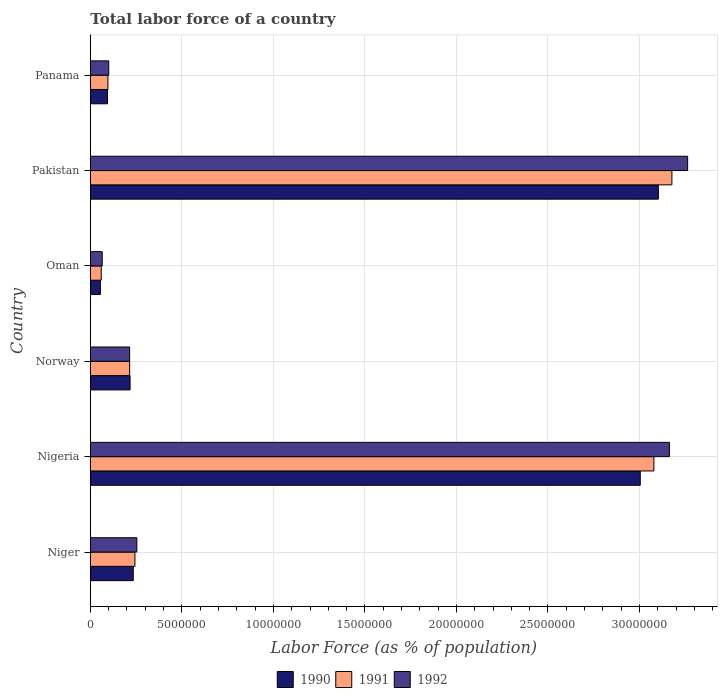How many different coloured bars are there?
Provide a succinct answer. 3. Are the number of bars on each tick of the Y-axis equal?
Your answer should be very brief. Yes. How many bars are there on the 1st tick from the bottom?
Your answer should be compact. 3. What is the label of the 1st group of bars from the top?
Make the answer very short. Panama. What is the percentage of labor force in 1991 in Niger?
Provide a short and direct response. 2.44e+06. Across all countries, what is the maximum percentage of labor force in 1991?
Provide a short and direct response. 3.18e+07. Across all countries, what is the minimum percentage of labor force in 1990?
Ensure brevity in your answer.  5.48e+05. In which country was the percentage of labor force in 1991 maximum?
Offer a very short reply. Pakistan. In which country was the percentage of labor force in 1990 minimum?
Make the answer very short. Oman. What is the total percentage of labor force in 1991 in the graph?
Give a very brief answer. 6.87e+07. What is the difference between the percentage of labor force in 1991 in Norway and that in Panama?
Offer a terse response. 1.18e+06. What is the difference between the percentage of labor force in 1990 in Norway and the percentage of labor force in 1991 in Oman?
Make the answer very short. 1.57e+06. What is the average percentage of labor force in 1992 per country?
Your answer should be compact. 1.18e+07. What is the difference between the percentage of labor force in 1990 and percentage of labor force in 1992 in Niger?
Make the answer very short. -1.97e+05. What is the ratio of the percentage of labor force in 1991 in Nigeria to that in Oman?
Provide a succinct answer. 51.79. What is the difference between the highest and the second highest percentage of labor force in 1990?
Offer a terse response. 9.88e+05. What is the difference between the highest and the lowest percentage of labor force in 1991?
Give a very brief answer. 3.12e+07. In how many countries, is the percentage of labor force in 1991 greater than the average percentage of labor force in 1991 taken over all countries?
Your answer should be compact. 2. Is the sum of the percentage of labor force in 1991 in Nigeria and Norway greater than the maximum percentage of labor force in 1992 across all countries?
Provide a short and direct response. Yes. What is the difference between two consecutive major ticks on the X-axis?
Keep it short and to the point. 5.00e+06. Are the values on the major ticks of X-axis written in scientific E-notation?
Provide a short and direct response. No. Does the graph contain grids?
Your answer should be compact. Yes. Where does the legend appear in the graph?
Give a very brief answer. Bottom center. How many legend labels are there?
Provide a succinct answer. 3. How are the legend labels stacked?
Give a very brief answer. Horizontal. What is the title of the graph?
Offer a very short reply. Total labor force of a country. What is the label or title of the X-axis?
Provide a short and direct response. Labor Force (as % of population). What is the Labor Force (as % of population) in 1990 in Niger?
Offer a terse response. 2.34e+06. What is the Labor Force (as % of population) in 1991 in Niger?
Offer a terse response. 2.44e+06. What is the Labor Force (as % of population) of 1992 in Niger?
Keep it short and to the point. 2.54e+06. What is the Labor Force (as % of population) of 1990 in Nigeria?
Offer a terse response. 3.00e+07. What is the Labor Force (as % of population) of 1991 in Nigeria?
Offer a terse response. 3.08e+07. What is the Labor Force (as % of population) in 1992 in Nigeria?
Your answer should be compact. 3.16e+07. What is the Labor Force (as % of population) in 1990 in Norway?
Provide a succinct answer. 2.17e+06. What is the Labor Force (as % of population) in 1991 in Norway?
Offer a very short reply. 2.14e+06. What is the Labor Force (as % of population) of 1992 in Norway?
Make the answer very short. 2.14e+06. What is the Labor Force (as % of population) of 1990 in Oman?
Give a very brief answer. 5.48e+05. What is the Labor Force (as % of population) of 1991 in Oman?
Ensure brevity in your answer.  5.94e+05. What is the Labor Force (as % of population) of 1992 in Oman?
Keep it short and to the point. 6.48e+05. What is the Labor Force (as % of population) of 1990 in Pakistan?
Keep it short and to the point. 3.10e+07. What is the Labor Force (as % of population) of 1991 in Pakistan?
Your response must be concise. 3.18e+07. What is the Labor Force (as % of population) in 1992 in Pakistan?
Provide a short and direct response. 3.26e+07. What is the Labor Force (as % of population) in 1990 in Panama?
Your answer should be compact. 9.38e+05. What is the Labor Force (as % of population) of 1991 in Panama?
Your answer should be very brief. 9.60e+05. What is the Labor Force (as % of population) in 1992 in Panama?
Your answer should be very brief. 1.01e+06. Across all countries, what is the maximum Labor Force (as % of population) in 1990?
Provide a short and direct response. 3.10e+07. Across all countries, what is the maximum Labor Force (as % of population) of 1991?
Keep it short and to the point. 3.18e+07. Across all countries, what is the maximum Labor Force (as % of population) in 1992?
Provide a short and direct response. 3.26e+07. Across all countries, what is the minimum Labor Force (as % of population) in 1990?
Keep it short and to the point. 5.48e+05. Across all countries, what is the minimum Labor Force (as % of population) in 1991?
Offer a terse response. 5.94e+05. Across all countries, what is the minimum Labor Force (as % of population) in 1992?
Offer a very short reply. 6.48e+05. What is the total Labor Force (as % of population) in 1990 in the graph?
Offer a very short reply. 6.71e+07. What is the total Labor Force (as % of population) in 1991 in the graph?
Provide a short and direct response. 6.87e+07. What is the total Labor Force (as % of population) in 1992 in the graph?
Offer a very short reply. 7.06e+07. What is the difference between the Labor Force (as % of population) of 1990 in Niger and that in Nigeria?
Provide a short and direct response. -2.77e+07. What is the difference between the Labor Force (as % of population) in 1991 in Niger and that in Nigeria?
Keep it short and to the point. -2.84e+07. What is the difference between the Labor Force (as % of population) in 1992 in Niger and that in Nigeria?
Ensure brevity in your answer.  -2.91e+07. What is the difference between the Labor Force (as % of population) in 1990 in Niger and that in Norway?
Your answer should be very brief. 1.74e+05. What is the difference between the Labor Force (as % of population) in 1991 in Niger and that in Norway?
Give a very brief answer. 2.91e+05. What is the difference between the Labor Force (as % of population) in 1992 in Niger and that in Norway?
Offer a terse response. 3.96e+05. What is the difference between the Labor Force (as % of population) in 1990 in Niger and that in Oman?
Offer a terse response. 1.80e+06. What is the difference between the Labor Force (as % of population) in 1991 in Niger and that in Oman?
Provide a short and direct response. 1.84e+06. What is the difference between the Labor Force (as % of population) in 1992 in Niger and that in Oman?
Ensure brevity in your answer.  1.89e+06. What is the difference between the Labor Force (as % of population) in 1990 in Niger and that in Pakistan?
Provide a succinct answer. -2.87e+07. What is the difference between the Labor Force (as % of population) of 1991 in Niger and that in Pakistan?
Offer a very short reply. -2.93e+07. What is the difference between the Labor Force (as % of population) in 1992 in Niger and that in Pakistan?
Make the answer very short. -3.01e+07. What is the difference between the Labor Force (as % of population) in 1990 in Niger and that in Panama?
Your answer should be very brief. 1.41e+06. What is the difference between the Labor Force (as % of population) in 1991 in Niger and that in Panama?
Provide a succinct answer. 1.48e+06. What is the difference between the Labor Force (as % of population) in 1992 in Niger and that in Panama?
Your answer should be very brief. 1.54e+06. What is the difference between the Labor Force (as % of population) of 1990 in Nigeria and that in Norway?
Offer a very short reply. 2.79e+07. What is the difference between the Labor Force (as % of population) of 1991 in Nigeria and that in Norway?
Offer a very short reply. 2.86e+07. What is the difference between the Labor Force (as % of population) of 1992 in Nigeria and that in Norway?
Keep it short and to the point. 2.95e+07. What is the difference between the Labor Force (as % of population) in 1990 in Nigeria and that in Oman?
Your response must be concise. 2.95e+07. What is the difference between the Labor Force (as % of population) in 1991 in Nigeria and that in Oman?
Offer a very short reply. 3.02e+07. What is the difference between the Labor Force (as % of population) in 1992 in Nigeria and that in Oman?
Keep it short and to the point. 3.10e+07. What is the difference between the Labor Force (as % of population) in 1990 in Nigeria and that in Pakistan?
Ensure brevity in your answer.  -9.88e+05. What is the difference between the Labor Force (as % of population) of 1991 in Nigeria and that in Pakistan?
Keep it short and to the point. -9.84e+05. What is the difference between the Labor Force (as % of population) in 1992 in Nigeria and that in Pakistan?
Provide a short and direct response. -9.96e+05. What is the difference between the Labor Force (as % of population) in 1990 in Nigeria and that in Panama?
Make the answer very short. 2.91e+07. What is the difference between the Labor Force (as % of population) of 1991 in Nigeria and that in Panama?
Provide a short and direct response. 2.98e+07. What is the difference between the Labor Force (as % of population) in 1992 in Nigeria and that in Panama?
Keep it short and to the point. 3.06e+07. What is the difference between the Labor Force (as % of population) of 1990 in Norway and that in Oman?
Provide a short and direct response. 1.62e+06. What is the difference between the Labor Force (as % of population) of 1991 in Norway and that in Oman?
Your answer should be compact. 1.55e+06. What is the difference between the Labor Force (as % of population) in 1992 in Norway and that in Oman?
Give a very brief answer. 1.50e+06. What is the difference between the Labor Force (as % of population) of 1990 in Norway and that in Pakistan?
Your answer should be very brief. -2.89e+07. What is the difference between the Labor Force (as % of population) of 1991 in Norway and that in Pakistan?
Offer a terse response. -2.96e+07. What is the difference between the Labor Force (as % of population) of 1992 in Norway and that in Pakistan?
Provide a short and direct response. -3.05e+07. What is the difference between the Labor Force (as % of population) of 1990 in Norway and that in Panama?
Your answer should be compact. 1.23e+06. What is the difference between the Labor Force (as % of population) of 1991 in Norway and that in Panama?
Provide a succinct answer. 1.18e+06. What is the difference between the Labor Force (as % of population) of 1992 in Norway and that in Panama?
Your answer should be very brief. 1.14e+06. What is the difference between the Labor Force (as % of population) of 1990 in Oman and that in Pakistan?
Offer a terse response. -3.05e+07. What is the difference between the Labor Force (as % of population) in 1991 in Oman and that in Pakistan?
Offer a very short reply. -3.12e+07. What is the difference between the Labor Force (as % of population) of 1992 in Oman and that in Pakistan?
Your answer should be compact. -3.20e+07. What is the difference between the Labor Force (as % of population) in 1990 in Oman and that in Panama?
Give a very brief answer. -3.90e+05. What is the difference between the Labor Force (as % of population) in 1991 in Oman and that in Panama?
Make the answer very short. -3.65e+05. What is the difference between the Labor Force (as % of population) in 1992 in Oman and that in Panama?
Provide a short and direct response. -3.57e+05. What is the difference between the Labor Force (as % of population) in 1990 in Pakistan and that in Panama?
Provide a short and direct response. 3.01e+07. What is the difference between the Labor Force (as % of population) in 1991 in Pakistan and that in Panama?
Provide a succinct answer. 3.08e+07. What is the difference between the Labor Force (as % of population) of 1992 in Pakistan and that in Panama?
Make the answer very short. 3.16e+07. What is the difference between the Labor Force (as % of population) of 1990 in Niger and the Labor Force (as % of population) of 1991 in Nigeria?
Your answer should be very brief. -2.84e+07. What is the difference between the Labor Force (as % of population) in 1990 in Niger and the Labor Force (as % of population) in 1992 in Nigeria?
Provide a short and direct response. -2.93e+07. What is the difference between the Labor Force (as % of population) of 1991 in Niger and the Labor Force (as % of population) of 1992 in Nigeria?
Offer a terse response. -2.92e+07. What is the difference between the Labor Force (as % of population) of 1990 in Niger and the Labor Force (as % of population) of 1991 in Norway?
Keep it short and to the point. 1.99e+05. What is the difference between the Labor Force (as % of population) of 1990 in Niger and the Labor Force (as % of population) of 1992 in Norway?
Provide a succinct answer. 1.99e+05. What is the difference between the Labor Force (as % of population) in 1991 in Niger and the Labor Force (as % of population) in 1992 in Norway?
Your response must be concise. 2.91e+05. What is the difference between the Labor Force (as % of population) of 1990 in Niger and the Labor Force (as % of population) of 1991 in Oman?
Offer a very short reply. 1.75e+06. What is the difference between the Labor Force (as % of population) of 1990 in Niger and the Labor Force (as % of population) of 1992 in Oman?
Give a very brief answer. 1.69e+06. What is the difference between the Labor Force (as % of population) of 1991 in Niger and the Labor Force (as % of population) of 1992 in Oman?
Keep it short and to the point. 1.79e+06. What is the difference between the Labor Force (as % of population) of 1990 in Niger and the Labor Force (as % of population) of 1991 in Pakistan?
Your answer should be very brief. -2.94e+07. What is the difference between the Labor Force (as % of population) in 1990 in Niger and the Labor Force (as % of population) in 1992 in Pakistan?
Offer a very short reply. -3.03e+07. What is the difference between the Labor Force (as % of population) of 1991 in Niger and the Labor Force (as % of population) of 1992 in Pakistan?
Your answer should be very brief. -3.02e+07. What is the difference between the Labor Force (as % of population) of 1990 in Niger and the Labor Force (as % of population) of 1991 in Panama?
Your answer should be very brief. 1.38e+06. What is the difference between the Labor Force (as % of population) in 1990 in Niger and the Labor Force (as % of population) in 1992 in Panama?
Your answer should be very brief. 1.34e+06. What is the difference between the Labor Force (as % of population) in 1991 in Niger and the Labor Force (as % of population) in 1992 in Panama?
Your response must be concise. 1.43e+06. What is the difference between the Labor Force (as % of population) in 1990 in Nigeria and the Labor Force (as % of population) in 1991 in Norway?
Offer a terse response. 2.79e+07. What is the difference between the Labor Force (as % of population) in 1990 in Nigeria and the Labor Force (as % of population) in 1992 in Norway?
Offer a terse response. 2.79e+07. What is the difference between the Labor Force (as % of population) of 1991 in Nigeria and the Labor Force (as % of population) of 1992 in Norway?
Offer a very short reply. 2.86e+07. What is the difference between the Labor Force (as % of population) of 1990 in Nigeria and the Labor Force (as % of population) of 1991 in Oman?
Provide a succinct answer. 2.94e+07. What is the difference between the Labor Force (as % of population) of 1990 in Nigeria and the Labor Force (as % of population) of 1992 in Oman?
Your answer should be very brief. 2.94e+07. What is the difference between the Labor Force (as % of population) of 1991 in Nigeria and the Labor Force (as % of population) of 1992 in Oman?
Your response must be concise. 3.01e+07. What is the difference between the Labor Force (as % of population) in 1990 in Nigeria and the Labor Force (as % of population) in 1991 in Pakistan?
Provide a succinct answer. -1.73e+06. What is the difference between the Labor Force (as % of population) of 1990 in Nigeria and the Labor Force (as % of population) of 1992 in Pakistan?
Your response must be concise. -2.59e+06. What is the difference between the Labor Force (as % of population) in 1991 in Nigeria and the Labor Force (as % of population) in 1992 in Pakistan?
Your answer should be very brief. -1.84e+06. What is the difference between the Labor Force (as % of population) of 1990 in Nigeria and the Labor Force (as % of population) of 1991 in Panama?
Offer a terse response. 2.91e+07. What is the difference between the Labor Force (as % of population) in 1990 in Nigeria and the Labor Force (as % of population) in 1992 in Panama?
Offer a very short reply. 2.90e+07. What is the difference between the Labor Force (as % of population) in 1991 in Nigeria and the Labor Force (as % of population) in 1992 in Panama?
Give a very brief answer. 2.98e+07. What is the difference between the Labor Force (as % of population) of 1990 in Norway and the Labor Force (as % of population) of 1991 in Oman?
Your answer should be compact. 1.57e+06. What is the difference between the Labor Force (as % of population) of 1990 in Norway and the Labor Force (as % of population) of 1992 in Oman?
Offer a very short reply. 1.52e+06. What is the difference between the Labor Force (as % of population) in 1991 in Norway and the Labor Force (as % of population) in 1992 in Oman?
Offer a terse response. 1.50e+06. What is the difference between the Labor Force (as % of population) in 1990 in Norway and the Labor Force (as % of population) in 1991 in Pakistan?
Your response must be concise. -2.96e+07. What is the difference between the Labor Force (as % of population) of 1990 in Norway and the Labor Force (as % of population) of 1992 in Pakistan?
Make the answer very short. -3.05e+07. What is the difference between the Labor Force (as % of population) in 1991 in Norway and the Labor Force (as % of population) in 1992 in Pakistan?
Provide a short and direct response. -3.05e+07. What is the difference between the Labor Force (as % of population) in 1990 in Norway and the Labor Force (as % of population) in 1991 in Panama?
Make the answer very short. 1.21e+06. What is the difference between the Labor Force (as % of population) in 1990 in Norway and the Labor Force (as % of population) in 1992 in Panama?
Your response must be concise. 1.16e+06. What is the difference between the Labor Force (as % of population) in 1991 in Norway and the Labor Force (as % of population) in 1992 in Panama?
Give a very brief answer. 1.14e+06. What is the difference between the Labor Force (as % of population) of 1990 in Oman and the Labor Force (as % of population) of 1991 in Pakistan?
Keep it short and to the point. -3.12e+07. What is the difference between the Labor Force (as % of population) in 1990 in Oman and the Labor Force (as % of population) in 1992 in Pakistan?
Provide a short and direct response. -3.21e+07. What is the difference between the Labor Force (as % of population) of 1991 in Oman and the Labor Force (as % of population) of 1992 in Pakistan?
Your response must be concise. -3.20e+07. What is the difference between the Labor Force (as % of population) in 1990 in Oman and the Labor Force (as % of population) in 1991 in Panama?
Give a very brief answer. -4.12e+05. What is the difference between the Labor Force (as % of population) of 1990 in Oman and the Labor Force (as % of population) of 1992 in Panama?
Your response must be concise. -4.58e+05. What is the difference between the Labor Force (as % of population) of 1991 in Oman and the Labor Force (as % of population) of 1992 in Panama?
Keep it short and to the point. -4.11e+05. What is the difference between the Labor Force (as % of population) of 1990 in Pakistan and the Labor Force (as % of population) of 1991 in Panama?
Offer a very short reply. 3.01e+07. What is the difference between the Labor Force (as % of population) in 1990 in Pakistan and the Labor Force (as % of population) in 1992 in Panama?
Your answer should be very brief. 3.00e+07. What is the difference between the Labor Force (as % of population) in 1991 in Pakistan and the Labor Force (as % of population) in 1992 in Panama?
Make the answer very short. 3.08e+07. What is the average Labor Force (as % of population) in 1990 per country?
Keep it short and to the point. 1.12e+07. What is the average Labor Force (as % of population) in 1991 per country?
Make the answer very short. 1.14e+07. What is the average Labor Force (as % of population) in 1992 per country?
Your answer should be compact. 1.18e+07. What is the difference between the Labor Force (as % of population) of 1990 and Labor Force (as % of population) of 1991 in Niger?
Offer a very short reply. -9.19e+04. What is the difference between the Labor Force (as % of population) of 1990 and Labor Force (as % of population) of 1992 in Niger?
Provide a short and direct response. -1.97e+05. What is the difference between the Labor Force (as % of population) of 1991 and Labor Force (as % of population) of 1992 in Niger?
Your response must be concise. -1.05e+05. What is the difference between the Labor Force (as % of population) of 1990 and Labor Force (as % of population) of 1991 in Nigeria?
Offer a very short reply. -7.44e+05. What is the difference between the Labor Force (as % of population) in 1990 and Labor Force (as % of population) in 1992 in Nigeria?
Your response must be concise. -1.59e+06. What is the difference between the Labor Force (as % of population) of 1991 and Labor Force (as % of population) of 1992 in Nigeria?
Offer a terse response. -8.47e+05. What is the difference between the Labor Force (as % of population) in 1990 and Labor Force (as % of population) in 1991 in Norway?
Offer a very short reply. 2.47e+04. What is the difference between the Labor Force (as % of population) of 1990 and Labor Force (as % of population) of 1992 in Norway?
Make the answer very short. 2.48e+04. What is the difference between the Labor Force (as % of population) in 1990 and Labor Force (as % of population) in 1991 in Oman?
Offer a very short reply. -4.68e+04. What is the difference between the Labor Force (as % of population) in 1990 and Labor Force (as % of population) in 1992 in Oman?
Ensure brevity in your answer.  -1.01e+05. What is the difference between the Labor Force (as % of population) in 1991 and Labor Force (as % of population) in 1992 in Oman?
Give a very brief answer. -5.39e+04. What is the difference between the Labor Force (as % of population) of 1990 and Labor Force (as % of population) of 1991 in Pakistan?
Offer a terse response. -7.40e+05. What is the difference between the Labor Force (as % of population) of 1990 and Labor Force (as % of population) of 1992 in Pakistan?
Your answer should be very brief. -1.60e+06. What is the difference between the Labor Force (as % of population) in 1991 and Labor Force (as % of population) in 1992 in Pakistan?
Your response must be concise. -8.59e+05. What is the difference between the Labor Force (as % of population) of 1990 and Labor Force (as % of population) of 1991 in Panama?
Offer a very short reply. -2.17e+04. What is the difference between the Labor Force (as % of population) in 1990 and Labor Force (as % of population) in 1992 in Panama?
Your response must be concise. -6.73e+04. What is the difference between the Labor Force (as % of population) of 1991 and Labor Force (as % of population) of 1992 in Panama?
Provide a succinct answer. -4.56e+04. What is the ratio of the Labor Force (as % of population) in 1990 in Niger to that in Nigeria?
Your response must be concise. 0.08. What is the ratio of the Labor Force (as % of population) in 1991 in Niger to that in Nigeria?
Offer a very short reply. 0.08. What is the ratio of the Labor Force (as % of population) of 1992 in Niger to that in Nigeria?
Offer a very short reply. 0.08. What is the ratio of the Labor Force (as % of population) of 1990 in Niger to that in Norway?
Your answer should be compact. 1.08. What is the ratio of the Labor Force (as % of population) of 1991 in Niger to that in Norway?
Keep it short and to the point. 1.14. What is the ratio of the Labor Force (as % of population) of 1992 in Niger to that in Norway?
Your answer should be very brief. 1.18. What is the ratio of the Labor Force (as % of population) of 1990 in Niger to that in Oman?
Offer a terse response. 4.28. What is the ratio of the Labor Force (as % of population) in 1991 in Niger to that in Oman?
Make the answer very short. 4.1. What is the ratio of the Labor Force (as % of population) of 1992 in Niger to that in Oman?
Provide a succinct answer. 3.92. What is the ratio of the Labor Force (as % of population) of 1990 in Niger to that in Pakistan?
Provide a succinct answer. 0.08. What is the ratio of the Labor Force (as % of population) in 1991 in Niger to that in Pakistan?
Keep it short and to the point. 0.08. What is the ratio of the Labor Force (as % of population) of 1992 in Niger to that in Pakistan?
Ensure brevity in your answer.  0.08. What is the ratio of the Labor Force (as % of population) of 1990 in Niger to that in Panama?
Provide a succinct answer. 2.5. What is the ratio of the Labor Force (as % of population) of 1991 in Niger to that in Panama?
Keep it short and to the point. 2.54. What is the ratio of the Labor Force (as % of population) of 1992 in Niger to that in Panama?
Offer a terse response. 2.53. What is the ratio of the Labor Force (as % of population) in 1990 in Nigeria to that in Norway?
Ensure brevity in your answer.  13.85. What is the ratio of the Labor Force (as % of population) of 1991 in Nigeria to that in Norway?
Offer a terse response. 14.36. What is the ratio of the Labor Force (as % of population) in 1992 in Nigeria to that in Norway?
Provide a succinct answer. 14.75. What is the ratio of the Labor Force (as % of population) in 1990 in Nigeria to that in Oman?
Provide a short and direct response. 54.86. What is the ratio of the Labor Force (as % of population) in 1991 in Nigeria to that in Oman?
Your answer should be compact. 51.79. What is the ratio of the Labor Force (as % of population) of 1992 in Nigeria to that in Oman?
Make the answer very short. 48.79. What is the ratio of the Labor Force (as % of population) of 1990 in Nigeria to that in Pakistan?
Ensure brevity in your answer.  0.97. What is the ratio of the Labor Force (as % of population) in 1991 in Nigeria to that in Pakistan?
Provide a short and direct response. 0.97. What is the ratio of the Labor Force (as % of population) of 1992 in Nigeria to that in Pakistan?
Offer a very short reply. 0.97. What is the ratio of the Labor Force (as % of population) of 1990 in Nigeria to that in Panama?
Your answer should be very brief. 32.03. What is the ratio of the Labor Force (as % of population) in 1991 in Nigeria to that in Panama?
Keep it short and to the point. 32.08. What is the ratio of the Labor Force (as % of population) of 1992 in Nigeria to that in Panama?
Keep it short and to the point. 31.47. What is the ratio of the Labor Force (as % of population) of 1990 in Norway to that in Oman?
Make the answer very short. 3.96. What is the ratio of the Labor Force (as % of population) in 1991 in Norway to that in Oman?
Provide a short and direct response. 3.61. What is the ratio of the Labor Force (as % of population) of 1992 in Norway to that in Oman?
Offer a very short reply. 3.31. What is the ratio of the Labor Force (as % of population) of 1990 in Norway to that in Pakistan?
Make the answer very short. 0.07. What is the ratio of the Labor Force (as % of population) in 1991 in Norway to that in Pakistan?
Offer a terse response. 0.07. What is the ratio of the Labor Force (as % of population) of 1992 in Norway to that in Pakistan?
Ensure brevity in your answer.  0.07. What is the ratio of the Labor Force (as % of population) in 1990 in Norway to that in Panama?
Your answer should be compact. 2.31. What is the ratio of the Labor Force (as % of population) of 1991 in Norway to that in Panama?
Provide a succinct answer. 2.23. What is the ratio of the Labor Force (as % of population) of 1992 in Norway to that in Panama?
Keep it short and to the point. 2.13. What is the ratio of the Labor Force (as % of population) of 1990 in Oman to that in Pakistan?
Provide a succinct answer. 0.02. What is the ratio of the Labor Force (as % of population) in 1991 in Oman to that in Pakistan?
Offer a terse response. 0.02. What is the ratio of the Labor Force (as % of population) of 1992 in Oman to that in Pakistan?
Keep it short and to the point. 0.02. What is the ratio of the Labor Force (as % of population) in 1990 in Oman to that in Panama?
Make the answer very short. 0.58. What is the ratio of the Labor Force (as % of population) of 1991 in Oman to that in Panama?
Provide a short and direct response. 0.62. What is the ratio of the Labor Force (as % of population) of 1992 in Oman to that in Panama?
Give a very brief answer. 0.65. What is the ratio of the Labor Force (as % of population) in 1990 in Pakistan to that in Panama?
Provide a short and direct response. 33.08. What is the ratio of the Labor Force (as % of population) in 1991 in Pakistan to that in Panama?
Make the answer very short. 33.11. What is the ratio of the Labor Force (as % of population) in 1992 in Pakistan to that in Panama?
Ensure brevity in your answer.  32.46. What is the difference between the highest and the second highest Labor Force (as % of population) of 1990?
Give a very brief answer. 9.88e+05. What is the difference between the highest and the second highest Labor Force (as % of population) in 1991?
Keep it short and to the point. 9.84e+05. What is the difference between the highest and the second highest Labor Force (as % of population) of 1992?
Offer a very short reply. 9.96e+05. What is the difference between the highest and the lowest Labor Force (as % of population) in 1990?
Make the answer very short. 3.05e+07. What is the difference between the highest and the lowest Labor Force (as % of population) in 1991?
Your answer should be compact. 3.12e+07. What is the difference between the highest and the lowest Labor Force (as % of population) of 1992?
Make the answer very short. 3.20e+07. 